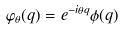Convert formula to latex. <formula><loc_0><loc_0><loc_500><loc_500>\varphi _ { \theta } ( q ) = e ^ { - i \theta q } \phi ( q )</formula> 